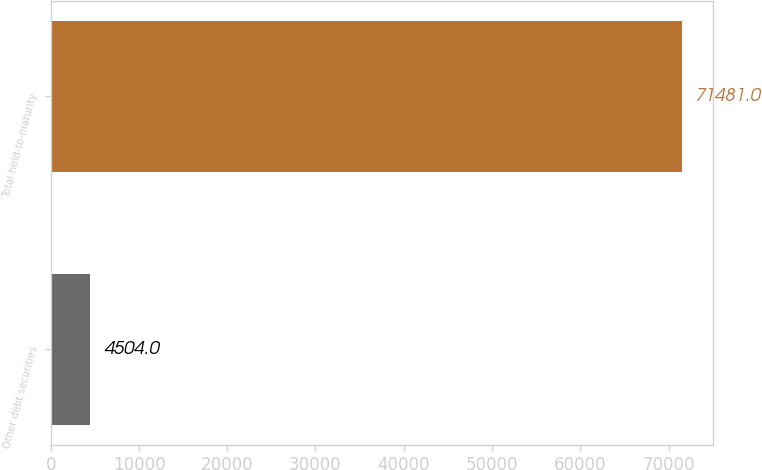Convert chart to OTSL. <chart><loc_0><loc_0><loc_500><loc_500><bar_chart><fcel>Other debt securities<fcel>Total held-to-maturity<nl><fcel>4504<fcel>71481<nl></chart> 